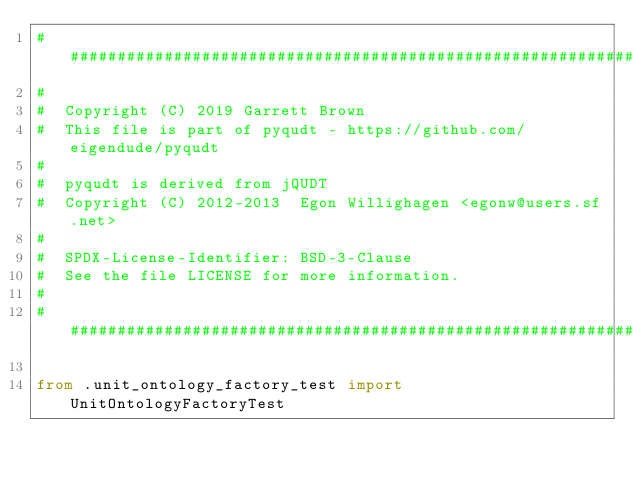<code> <loc_0><loc_0><loc_500><loc_500><_Python_>################################################################################
#
#  Copyright (C) 2019 Garrett Brown
#  This file is part of pyqudt - https://github.com/eigendude/pyqudt
#
#  pyqudt is derived from jQUDT
#  Copyright (C) 2012-2013  Egon Willighagen <egonw@users.sf.net>
#
#  SPDX-License-Identifier: BSD-3-Clause
#  See the file LICENSE for more information.
#
################################################################################

from .unit_ontology_factory_test import UnitOntologyFactoryTest
</code> 